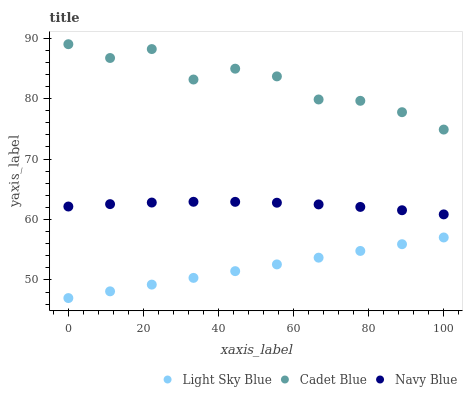Does Light Sky Blue have the minimum area under the curve?
Answer yes or no. Yes. Does Cadet Blue have the maximum area under the curve?
Answer yes or no. Yes. Does Navy Blue have the minimum area under the curve?
Answer yes or no. No. Does Navy Blue have the maximum area under the curve?
Answer yes or no. No. Is Light Sky Blue the smoothest?
Answer yes or no. Yes. Is Cadet Blue the roughest?
Answer yes or no. Yes. Is Navy Blue the smoothest?
Answer yes or no. No. Is Navy Blue the roughest?
Answer yes or no. No. Does Light Sky Blue have the lowest value?
Answer yes or no. Yes. Does Navy Blue have the lowest value?
Answer yes or no. No. Does Cadet Blue have the highest value?
Answer yes or no. Yes. Does Navy Blue have the highest value?
Answer yes or no. No. Is Navy Blue less than Cadet Blue?
Answer yes or no. Yes. Is Cadet Blue greater than Light Sky Blue?
Answer yes or no. Yes. Does Navy Blue intersect Cadet Blue?
Answer yes or no. No. 